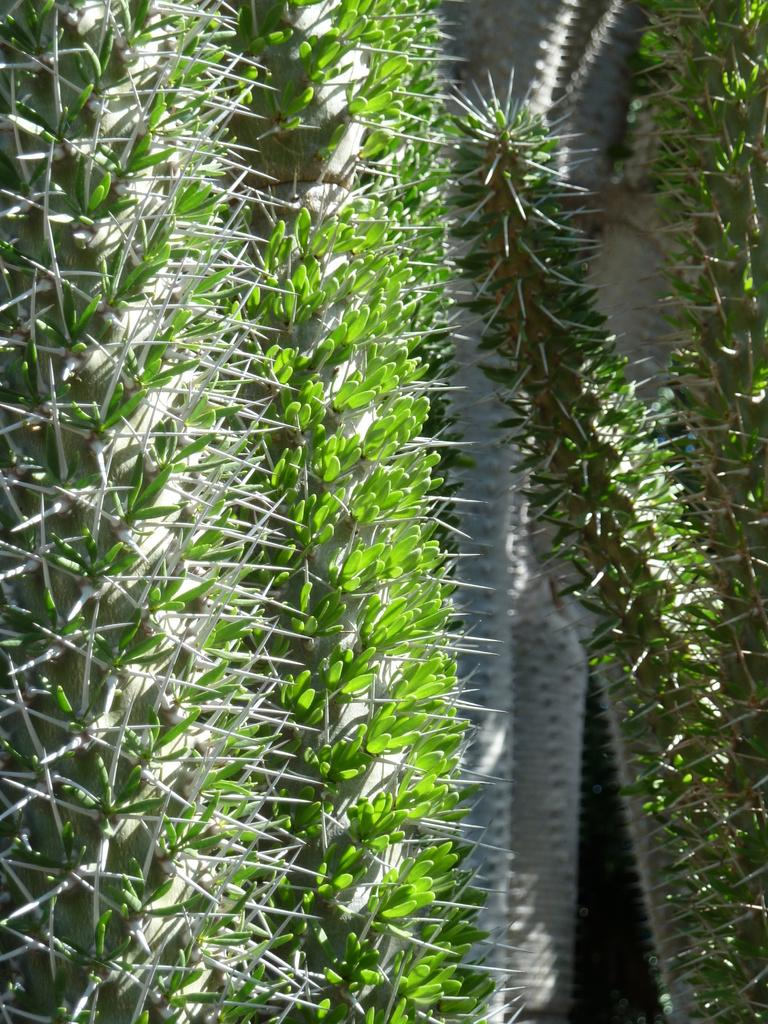What type of living organisms can be seen in the image? Plants can be seen in the image. What type of basin is used to store the knowledge in the image? There is no basin or knowledge present in the image; it only features plants. 